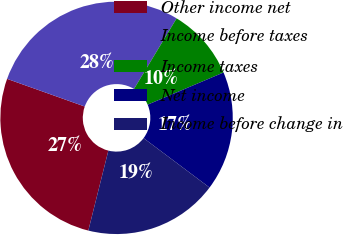<chart> <loc_0><loc_0><loc_500><loc_500><pie_chart><fcel>Other income net<fcel>Income before taxes<fcel>Income taxes<fcel>Net income<fcel>Income before change in<nl><fcel>26.54%<fcel>28.2%<fcel>9.97%<fcel>16.62%<fcel>18.67%<nl></chart> 